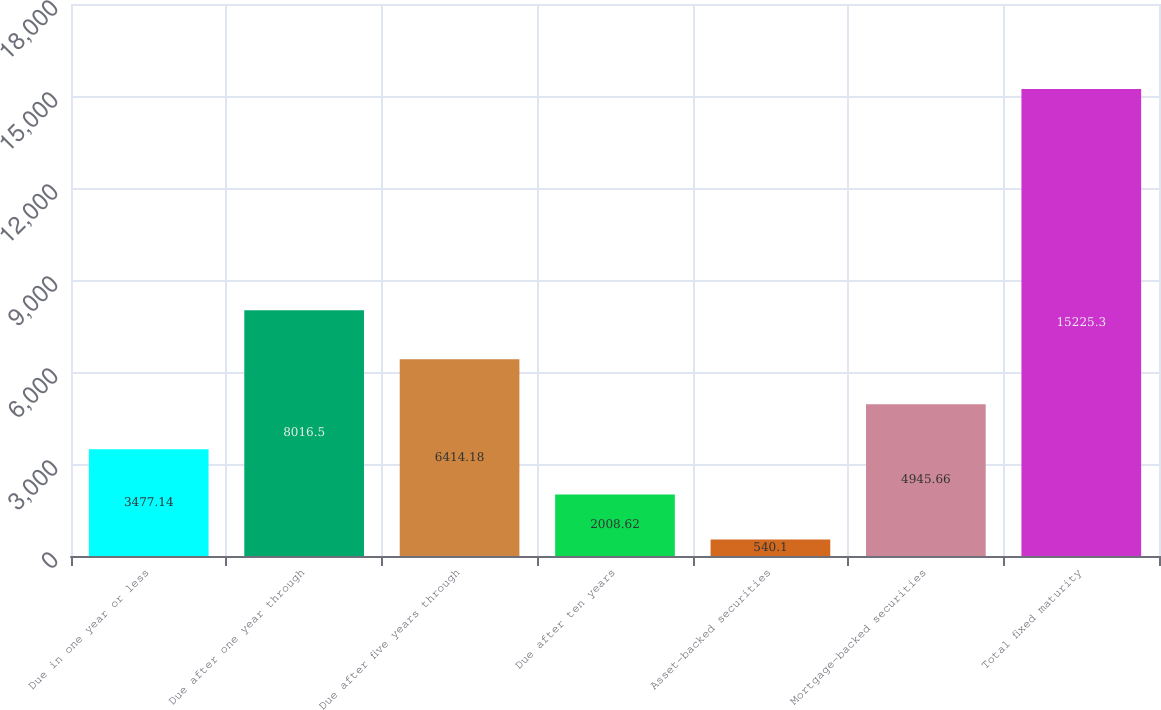<chart> <loc_0><loc_0><loc_500><loc_500><bar_chart><fcel>Due in one year or less<fcel>Due after one year through<fcel>Due after five years through<fcel>Due after ten years<fcel>Asset-backed securities<fcel>Mortgage-backed securities<fcel>Total fixed maturity<nl><fcel>3477.14<fcel>8016.5<fcel>6414.18<fcel>2008.62<fcel>540.1<fcel>4945.66<fcel>15225.3<nl></chart> 